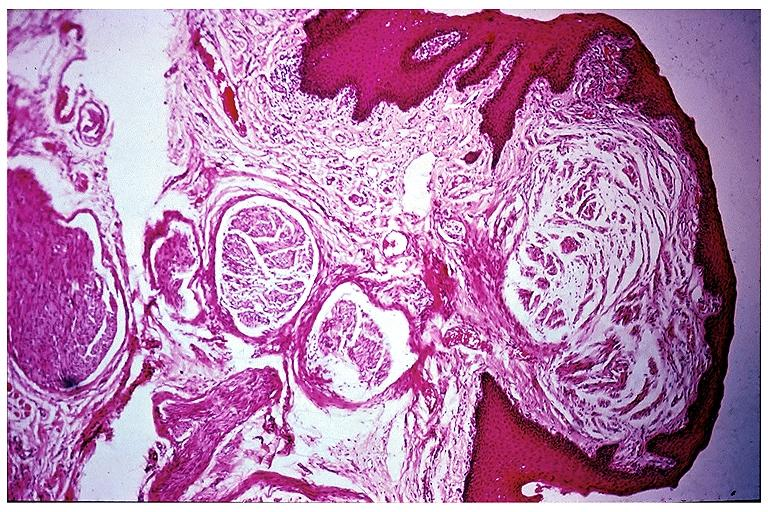what does this image show?
Answer the question using a single word or phrase. Multiple endocrine neoplasia type ii b-neuroma 